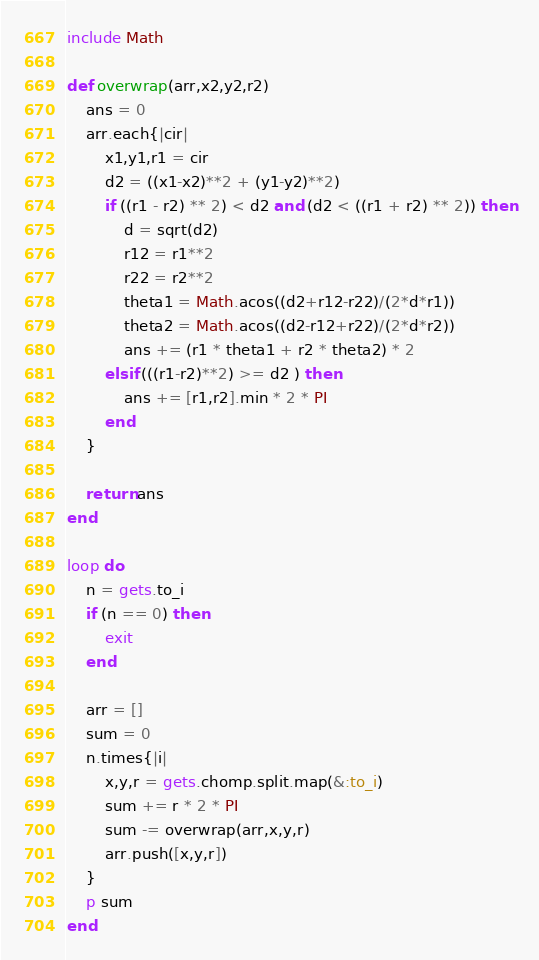<code> <loc_0><loc_0><loc_500><loc_500><_Ruby_>include Math

def overwrap(arr,x2,y2,r2)
	ans = 0
	arr.each{|cir|
		x1,y1,r1 = cir
		d2 = ((x1-x2)**2 + (y1-y2)**2)
		if ((r1 - r2) ** 2) < d2 and (d2 < ((r1 + r2) ** 2)) then
			d = sqrt(d2)
			r12 = r1**2
			r22 = r2**2
			theta1 = Math.acos((d2+r12-r22)/(2*d*r1))
			theta2 = Math.acos((d2-r12+r22)/(2*d*r2))
			ans += (r1 * theta1 + r2 * theta2) * 2
		elsif (((r1-r2)**2) >= d2 ) then
			ans += [r1,r2].min * 2 * PI
		end
	}
	
	return ans
end

loop do
	n = gets.to_i
	if (n == 0) then
		exit
	end
	
	arr = []
	sum = 0
	n.times{|i|	
		x,y,r = gets.chomp.split.map(&:to_i)
		sum += r * 2 * PI
		sum -= overwrap(arr,x,y,r)
		arr.push([x,y,r])
	}
	p sum
end</code> 